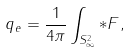<formula> <loc_0><loc_0><loc_500><loc_500>q _ { e } = \frac { 1 } { 4 \pi } \int _ { S ^ { 2 } _ { \infty } } * F ,</formula> 